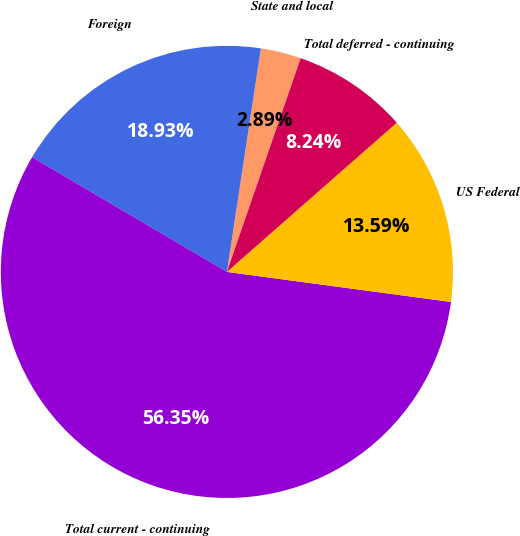<chart> <loc_0><loc_0><loc_500><loc_500><pie_chart><fcel>State and local<fcel>Foreign<fcel>Total current - continuing<fcel>US Federal<fcel>Total deferred - continuing<nl><fcel>2.89%<fcel>18.93%<fcel>56.35%<fcel>13.59%<fcel>8.24%<nl></chart> 